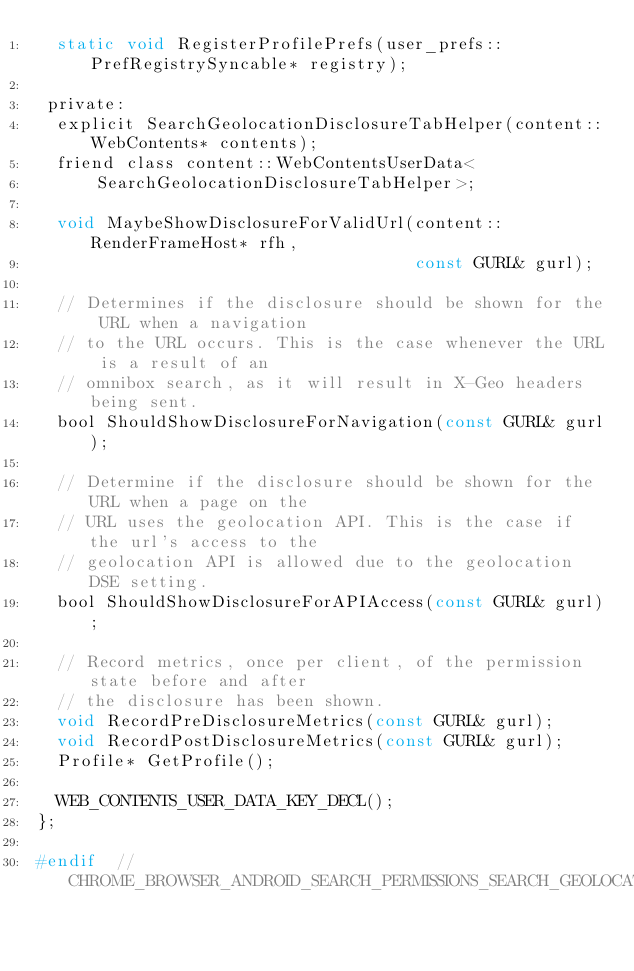<code> <loc_0><loc_0><loc_500><loc_500><_C_>  static void RegisterProfilePrefs(user_prefs::PrefRegistrySyncable* registry);

 private:
  explicit SearchGeolocationDisclosureTabHelper(content::WebContents* contents);
  friend class content::WebContentsUserData<
      SearchGeolocationDisclosureTabHelper>;

  void MaybeShowDisclosureForValidUrl(content::RenderFrameHost* rfh,
                                      const GURL& gurl);

  // Determines if the disclosure should be shown for the URL when a navigation
  // to the URL occurs. This is the case whenever the URL is a result of an
  // omnibox search, as it will result in X-Geo headers being sent.
  bool ShouldShowDisclosureForNavigation(const GURL& gurl);

  // Determine if the disclosure should be shown for the URL when a page on the
  // URL uses the geolocation API. This is the case if the url's access to the
  // geolocation API is allowed due to the geolocation DSE setting.
  bool ShouldShowDisclosureForAPIAccess(const GURL& gurl);

  // Record metrics, once per client, of the permission state before and after
  // the disclosure has been shown.
  void RecordPreDisclosureMetrics(const GURL& gurl);
  void RecordPostDisclosureMetrics(const GURL& gurl);
  Profile* GetProfile();

  WEB_CONTENTS_USER_DATA_KEY_DECL();
};

#endif  // CHROME_BROWSER_ANDROID_SEARCH_PERMISSIONS_SEARCH_GEOLOCATION_DISCLOSURE_TAB_HELPER_H_
</code> 